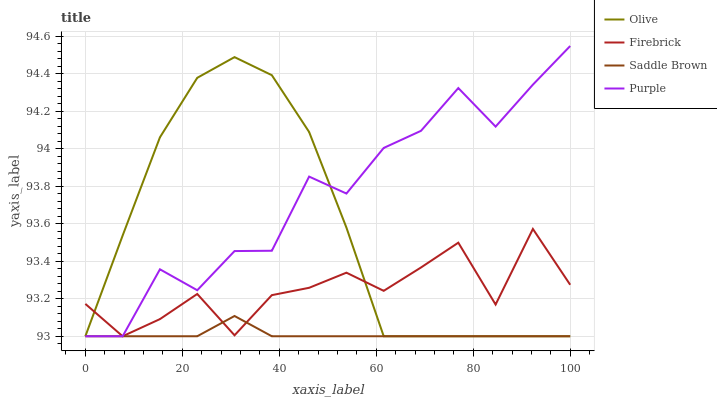Does Saddle Brown have the minimum area under the curve?
Answer yes or no. Yes. Does Purple have the maximum area under the curve?
Answer yes or no. Yes. Does Firebrick have the minimum area under the curve?
Answer yes or no. No. Does Firebrick have the maximum area under the curve?
Answer yes or no. No. Is Saddle Brown the smoothest?
Answer yes or no. Yes. Is Purple the roughest?
Answer yes or no. Yes. Is Firebrick the smoothest?
Answer yes or no. No. Is Firebrick the roughest?
Answer yes or no. No. Does Olive have the lowest value?
Answer yes or no. Yes. Does Purple have the highest value?
Answer yes or no. Yes. Does Firebrick have the highest value?
Answer yes or no. No. Does Olive intersect Saddle Brown?
Answer yes or no. Yes. Is Olive less than Saddle Brown?
Answer yes or no. No. Is Olive greater than Saddle Brown?
Answer yes or no. No. 